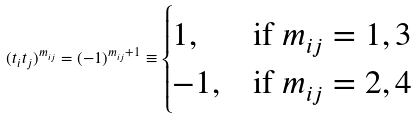Convert formula to latex. <formula><loc_0><loc_0><loc_500><loc_500>( t _ { i } t _ { j } ) ^ { m _ { i j } } = ( - 1 ) ^ { m _ { i j } + 1 } \equiv \begin{cases} 1 , & \text {if } m _ { i j } = 1 , 3 \\ - 1 , & \text {if } m _ { i j } = 2 , 4 \end{cases}</formula> 